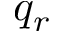<formula> <loc_0><loc_0><loc_500><loc_500>q _ { r }</formula> 